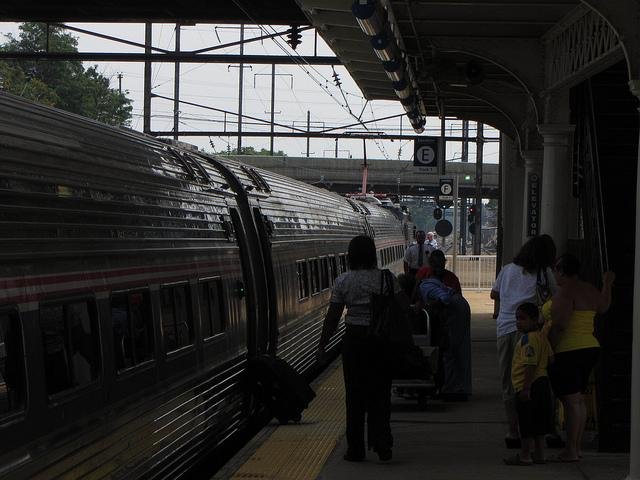What sort of power moves this vehicle? electric 